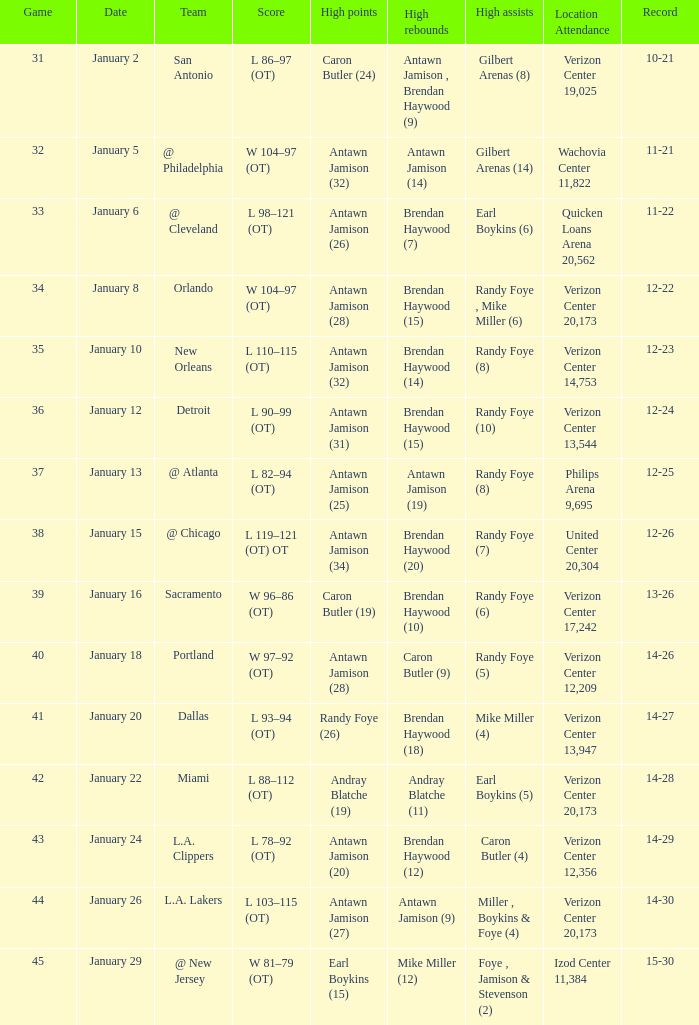Who had the highest points on January 2? Caron Butler (24). 